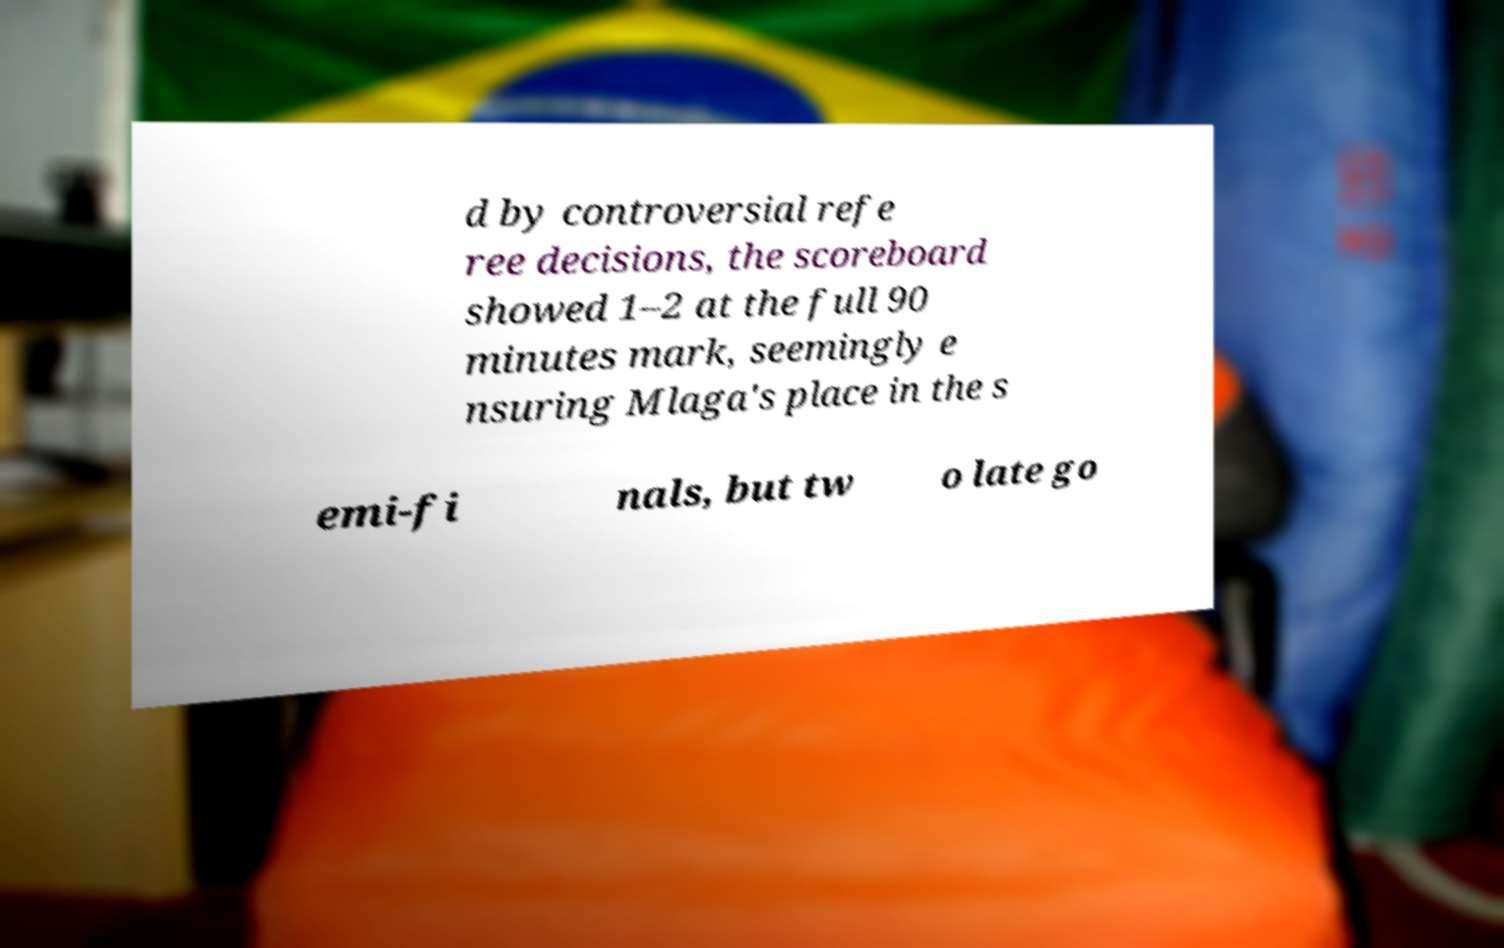Can you read and provide the text displayed in the image?This photo seems to have some interesting text. Can you extract and type it out for me? d by controversial refe ree decisions, the scoreboard showed 1–2 at the full 90 minutes mark, seemingly e nsuring Mlaga's place in the s emi-fi nals, but tw o late go 